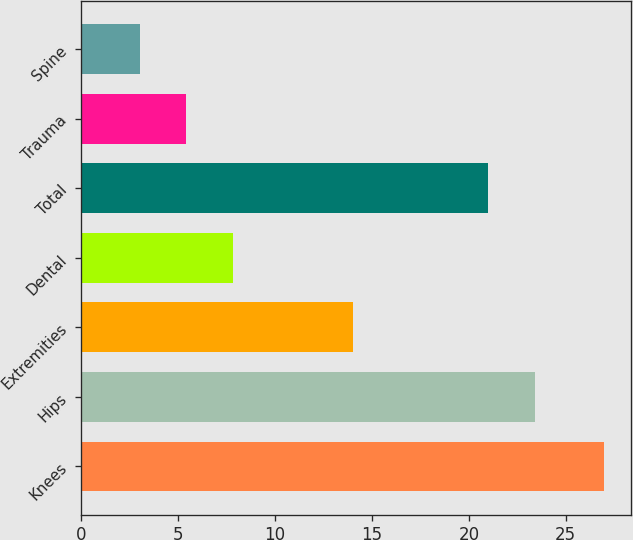<chart> <loc_0><loc_0><loc_500><loc_500><bar_chart><fcel>Knees<fcel>Hips<fcel>Extremities<fcel>Dental<fcel>Total<fcel>Trauma<fcel>Spine<nl><fcel>27<fcel>23.4<fcel>14<fcel>7.8<fcel>21<fcel>5.4<fcel>3<nl></chart> 